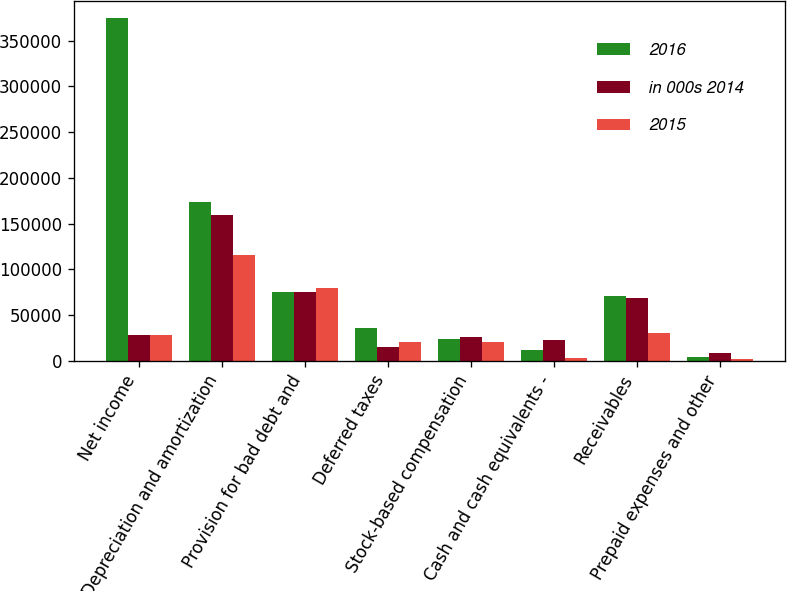Convert chart to OTSL. <chart><loc_0><loc_0><loc_500><loc_500><stacked_bar_chart><ecel><fcel>Net income<fcel>Depreciation and amortization<fcel>Provision for bad debt and<fcel>Deferred taxes<fcel>Stock-based compensation<fcel>Cash and cash equivalents -<fcel>Receivables<fcel>Prepaid expenses and other<nl><fcel>2016<fcel>374267<fcel>173598<fcel>75395<fcel>36276<fcel>23540<fcel>12159<fcel>70721<fcel>4321<nl><fcel>in 000s 2014<fcel>28222<fcel>159804<fcel>74993<fcel>15502<fcel>26068<fcel>23252<fcel>68109<fcel>8542<nl><fcel>2015<fcel>28222<fcel>115604<fcel>80007<fcel>20958<fcel>20058<fcel>2522<fcel>30376<fcel>2293<nl></chart> 